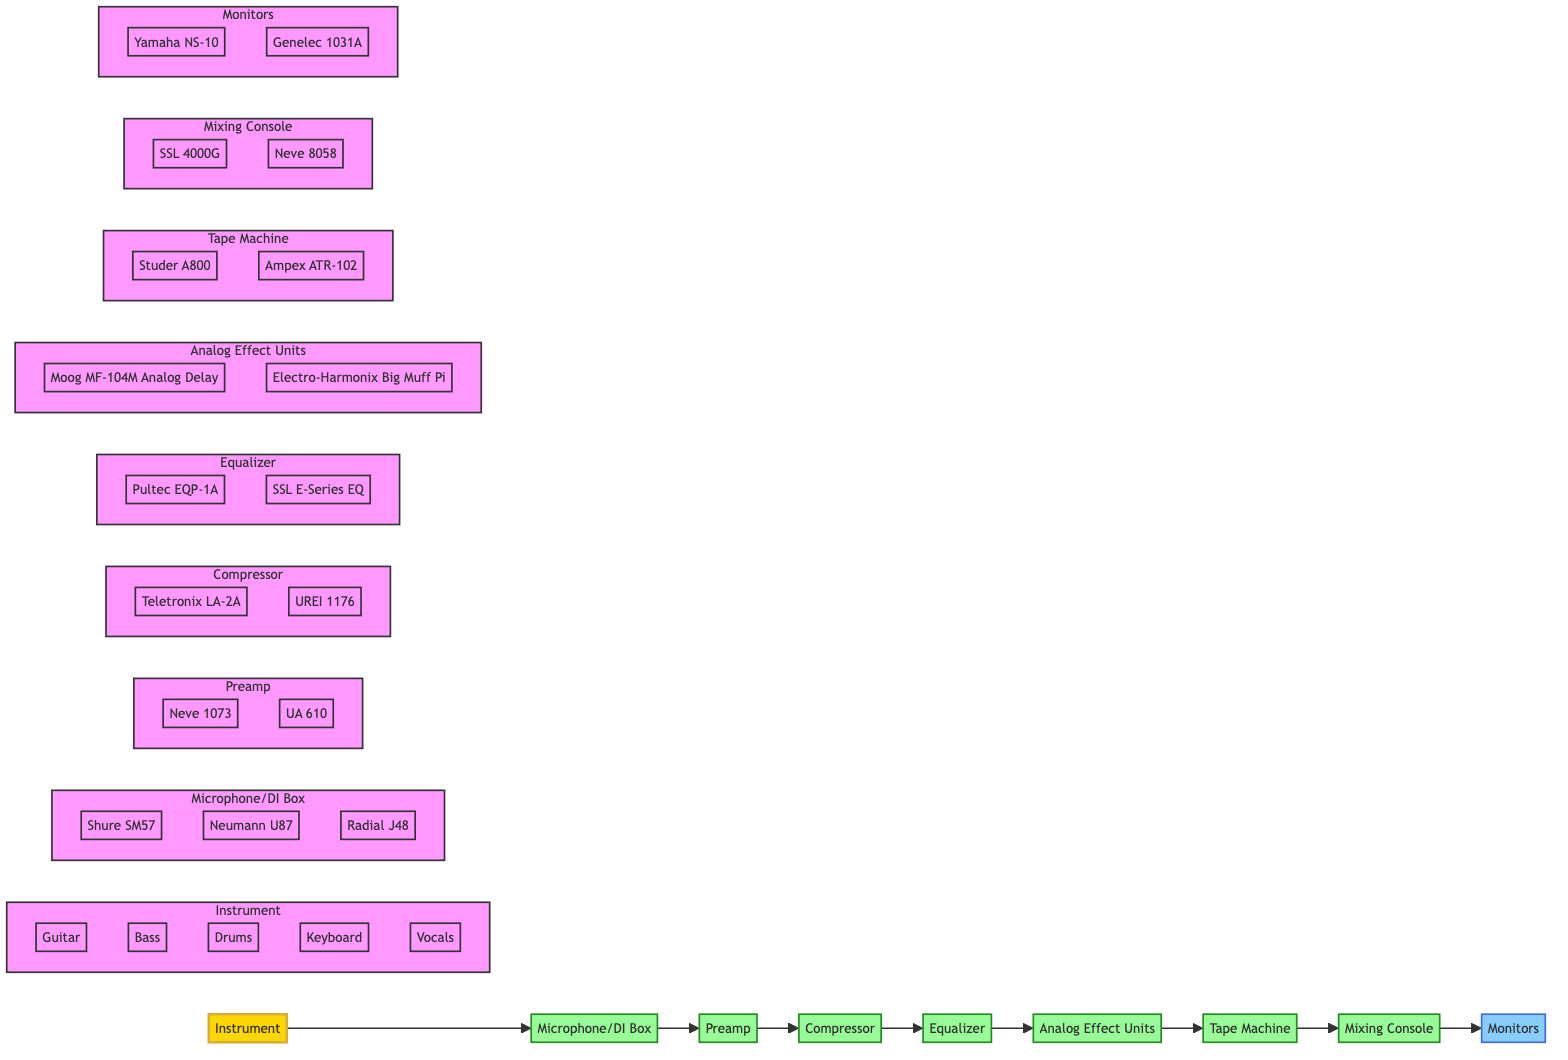What is the first component in the signal flow? The diagram starts with the "Instrument" node, which represents the first component in the recording signal flow.
Answer: Instrument How many types of instruments are included? The "Instrument" node lists five specific types: Guitar, Bass, Drums, Keyboard, and Vocals, indicating there are five types of instruments.
Answer: Five What are the two options for the Tape Machine? The "Tape Machine" node includes two options: Studer A800 and Ampex ATR-102 as the available tape machines in the recording setup.
Answer: Studer A800, Ampex ATR-102 Which component comes after the Equalizer? Following the "Equalizer" in the signal flow is the "Analog Effect Units," which are the next component in the processing chain.
Answer: Analog Effect Units What is the relationship between the Microphone and DI Box? The "Microphone/DI Box" is a combined node in the diagram, indicating that both the microphone and DI box are used in parallel for input before reaching the preamp.
Answer: Combined node for input Which preamp model is listed last in the Preamp subgraph? Within the "Preamp" subgraph, the last model mentioned is API 512c, which represents one of the available preamps in the signal chain.
Answer: API 512c What is the final output of the signal flow? The last node in the signal flow is "Monitors," indicating that this is the output component where the final mix is played back.
Answer: Monitors How many processing stages are there before the Tape Machine? The flowchart indicates five processing stages (Compressor, Equalizer, Analog Effect Units, Preamp, and Microphone/DI Box) before reaching the "Tape Machine."
Answer: Five Which component directly precedes the Mixing Console? The "Tape Machine" component directly precedes the "Mixing Console" in the recording signal flow, indicating the order of processing.
Answer: Tape Machine 